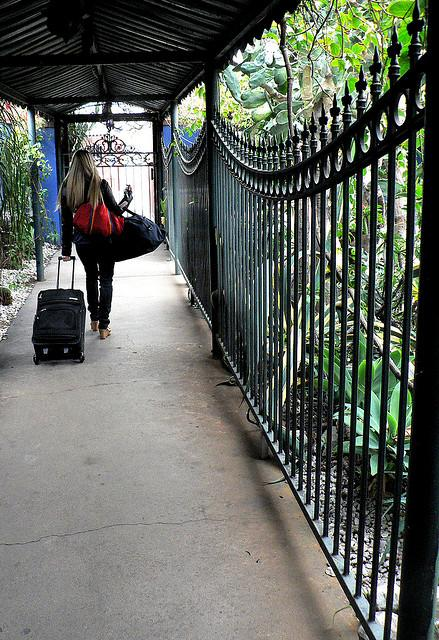Where is the woman likely heading? airport 